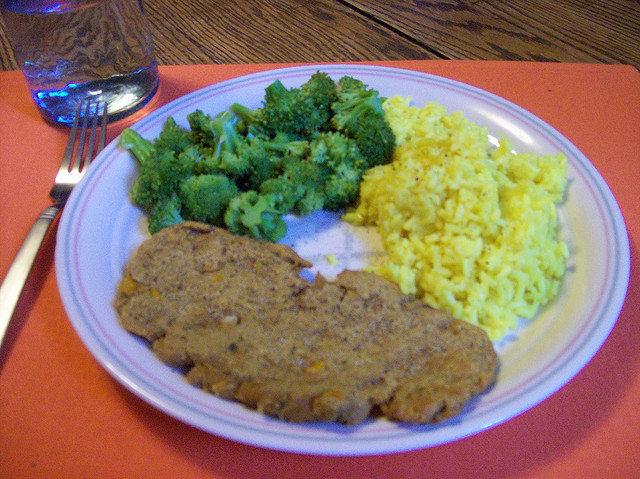How many different types of foods are here? There are three distinct types of foods visible on the plate: a portion of meatloaf, a serving of broccoli, and a scoop of yellow rice. Each type offers a unique flavor and nutritional profile to the meal. 